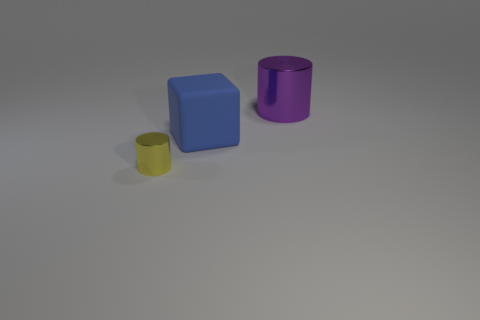Add 1 small cyan objects. How many objects exist? 4 Subtract all cylinders. How many objects are left? 1 Add 2 matte things. How many matte things exist? 3 Subtract 1 purple cylinders. How many objects are left? 2 Subtract all large matte blocks. Subtract all yellow cylinders. How many objects are left? 1 Add 3 small metal objects. How many small metal objects are left? 4 